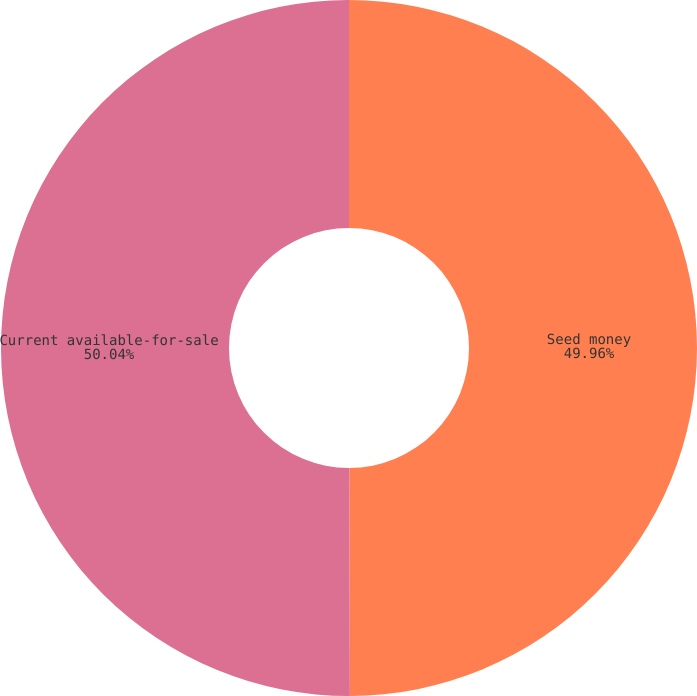Convert chart. <chart><loc_0><loc_0><loc_500><loc_500><pie_chart><fcel>Seed money<fcel>Current available-for-sale<nl><fcel>49.96%<fcel>50.04%<nl></chart> 